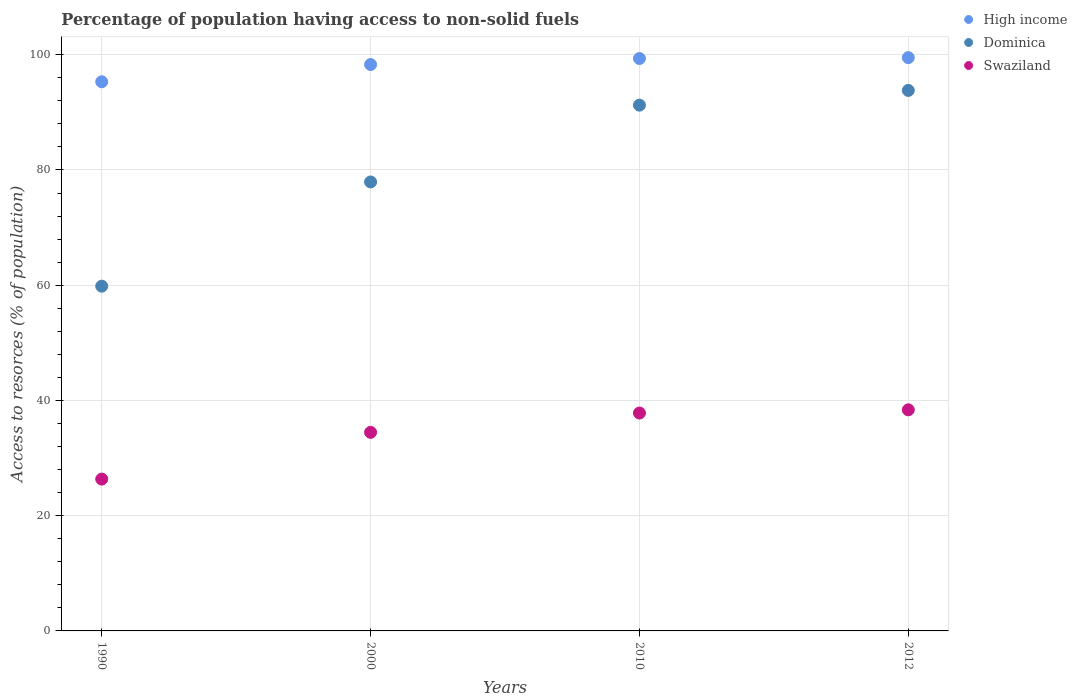Is the number of dotlines equal to the number of legend labels?
Your answer should be very brief. Yes. What is the percentage of population having access to non-solid fuels in Swaziland in 1990?
Offer a terse response. 26.35. Across all years, what is the maximum percentage of population having access to non-solid fuels in Dominica?
Give a very brief answer. 93.81. Across all years, what is the minimum percentage of population having access to non-solid fuels in Dominica?
Provide a succinct answer. 59.83. What is the total percentage of population having access to non-solid fuels in Swaziland in the graph?
Give a very brief answer. 137. What is the difference between the percentage of population having access to non-solid fuels in High income in 2000 and that in 2010?
Your response must be concise. -1.04. What is the difference between the percentage of population having access to non-solid fuels in Swaziland in 2000 and the percentage of population having access to non-solid fuels in High income in 2012?
Give a very brief answer. -65.03. What is the average percentage of population having access to non-solid fuels in Swaziland per year?
Make the answer very short. 34.25. In the year 2012, what is the difference between the percentage of population having access to non-solid fuels in High income and percentage of population having access to non-solid fuels in Dominica?
Make the answer very short. 5.69. In how many years, is the percentage of population having access to non-solid fuels in High income greater than 64 %?
Offer a terse response. 4. What is the ratio of the percentage of population having access to non-solid fuels in High income in 1990 to that in 2010?
Your response must be concise. 0.96. What is the difference between the highest and the second highest percentage of population having access to non-solid fuels in Dominica?
Provide a succinct answer. 2.56. What is the difference between the highest and the lowest percentage of population having access to non-solid fuels in Dominica?
Keep it short and to the point. 33.97. In how many years, is the percentage of population having access to non-solid fuels in Swaziland greater than the average percentage of population having access to non-solid fuels in Swaziland taken over all years?
Your answer should be compact. 3. Is it the case that in every year, the sum of the percentage of population having access to non-solid fuels in Swaziland and percentage of population having access to non-solid fuels in Dominica  is greater than the percentage of population having access to non-solid fuels in High income?
Your answer should be compact. No. Does the percentage of population having access to non-solid fuels in High income monotonically increase over the years?
Give a very brief answer. Yes. How many dotlines are there?
Make the answer very short. 3. Does the graph contain any zero values?
Keep it short and to the point. No. How many legend labels are there?
Your answer should be compact. 3. How are the legend labels stacked?
Offer a terse response. Vertical. What is the title of the graph?
Offer a terse response. Percentage of population having access to non-solid fuels. What is the label or title of the Y-axis?
Make the answer very short. Access to resorces (% of population). What is the Access to resorces (% of population) in High income in 1990?
Give a very brief answer. 95.31. What is the Access to resorces (% of population) in Dominica in 1990?
Your answer should be very brief. 59.83. What is the Access to resorces (% of population) of Swaziland in 1990?
Keep it short and to the point. 26.35. What is the Access to resorces (% of population) in High income in 2000?
Ensure brevity in your answer.  98.3. What is the Access to resorces (% of population) of Dominica in 2000?
Give a very brief answer. 77.92. What is the Access to resorces (% of population) of Swaziland in 2000?
Provide a succinct answer. 34.46. What is the Access to resorces (% of population) in High income in 2010?
Provide a succinct answer. 99.34. What is the Access to resorces (% of population) of Dominica in 2010?
Provide a short and direct response. 91.25. What is the Access to resorces (% of population) of Swaziland in 2010?
Provide a short and direct response. 37.82. What is the Access to resorces (% of population) in High income in 2012?
Keep it short and to the point. 99.49. What is the Access to resorces (% of population) of Dominica in 2012?
Offer a very short reply. 93.81. What is the Access to resorces (% of population) of Swaziland in 2012?
Ensure brevity in your answer.  38.37. Across all years, what is the maximum Access to resorces (% of population) in High income?
Your response must be concise. 99.49. Across all years, what is the maximum Access to resorces (% of population) in Dominica?
Give a very brief answer. 93.81. Across all years, what is the maximum Access to resorces (% of population) in Swaziland?
Offer a terse response. 38.37. Across all years, what is the minimum Access to resorces (% of population) of High income?
Provide a short and direct response. 95.31. Across all years, what is the minimum Access to resorces (% of population) of Dominica?
Your answer should be compact. 59.83. Across all years, what is the minimum Access to resorces (% of population) in Swaziland?
Make the answer very short. 26.35. What is the total Access to resorces (% of population) in High income in the graph?
Give a very brief answer. 392.44. What is the total Access to resorces (% of population) in Dominica in the graph?
Your response must be concise. 322.81. What is the total Access to resorces (% of population) in Swaziland in the graph?
Your answer should be compact. 137. What is the difference between the Access to resorces (% of population) of High income in 1990 and that in 2000?
Ensure brevity in your answer.  -2.99. What is the difference between the Access to resorces (% of population) of Dominica in 1990 and that in 2000?
Keep it short and to the point. -18.09. What is the difference between the Access to resorces (% of population) in Swaziland in 1990 and that in 2000?
Provide a succinct answer. -8.11. What is the difference between the Access to resorces (% of population) of High income in 1990 and that in 2010?
Your answer should be very brief. -4.04. What is the difference between the Access to resorces (% of population) in Dominica in 1990 and that in 2010?
Provide a succinct answer. -31.42. What is the difference between the Access to resorces (% of population) of Swaziland in 1990 and that in 2010?
Make the answer very short. -11.47. What is the difference between the Access to resorces (% of population) of High income in 1990 and that in 2012?
Your answer should be very brief. -4.19. What is the difference between the Access to resorces (% of population) in Dominica in 1990 and that in 2012?
Give a very brief answer. -33.97. What is the difference between the Access to resorces (% of population) in Swaziland in 1990 and that in 2012?
Your response must be concise. -12.02. What is the difference between the Access to resorces (% of population) in High income in 2000 and that in 2010?
Your response must be concise. -1.04. What is the difference between the Access to resorces (% of population) in Dominica in 2000 and that in 2010?
Your answer should be compact. -13.33. What is the difference between the Access to resorces (% of population) in Swaziland in 2000 and that in 2010?
Make the answer very short. -3.36. What is the difference between the Access to resorces (% of population) of High income in 2000 and that in 2012?
Your answer should be compact. -1.2. What is the difference between the Access to resorces (% of population) in Dominica in 2000 and that in 2012?
Give a very brief answer. -15.89. What is the difference between the Access to resorces (% of population) of Swaziland in 2000 and that in 2012?
Keep it short and to the point. -3.91. What is the difference between the Access to resorces (% of population) in High income in 2010 and that in 2012?
Your response must be concise. -0.15. What is the difference between the Access to resorces (% of population) of Dominica in 2010 and that in 2012?
Your answer should be very brief. -2.56. What is the difference between the Access to resorces (% of population) of Swaziland in 2010 and that in 2012?
Your response must be concise. -0.56. What is the difference between the Access to resorces (% of population) in High income in 1990 and the Access to resorces (% of population) in Dominica in 2000?
Make the answer very short. 17.39. What is the difference between the Access to resorces (% of population) of High income in 1990 and the Access to resorces (% of population) of Swaziland in 2000?
Give a very brief answer. 60.85. What is the difference between the Access to resorces (% of population) of Dominica in 1990 and the Access to resorces (% of population) of Swaziland in 2000?
Offer a terse response. 25.37. What is the difference between the Access to resorces (% of population) of High income in 1990 and the Access to resorces (% of population) of Dominica in 2010?
Provide a succinct answer. 4.06. What is the difference between the Access to resorces (% of population) of High income in 1990 and the Access to resorces (% of population) of Swaziland in 2010?
Give a very brief answer. 57.49. What is the difference between the Access to resorces (% of population) of Dominica in 1990 and the Access to resorces (% of population) of Swaziland in 2010?
Your response must be concise. 22.02. What is the difference between the Access to resorces (% of population) in High income in 1990 and the Access to resorces (% of population) in Dominica in 2012?
Give a very brief answer. 1.5. What is the difference between the Access to resorces (% of population) of High income in 1990 and the Access to resorces (% of population) of Swaziland in 2012?
Ensure brevity in your answer.  56.93. What is the difference between the Access to resorces (% of population) of Dominica in 1990 and the Access to resorces (% of population) of Swaziland in 2012?
Provide a succinct answer. 21.46. What is the difference between the Access to resorces (% of population) in High income in 2000 and the Access to resorces (% of population) in Dominica in 2010?
Offer a very short reply. 7.05. What is the difference between the Access to resorces (% of population) in High income in 2000 and the Access to resorces (% of population) in Swaziland in 2010?
Your response must be concise. 60.48. What is the difference between the Access to resorces (% of population) of Dominica in 2000 and the Access to resorces (% of population) of Swaziland in 2010?
Your answer should be very brief. 40.1. What is the difference between the Access to resorces (% of population) of High income in 2000 and the Access to resorces (% of population) of Dominica in 2012?
Offer a very short reply. 4.49. What is the difference between the Access to resorces (% of population) in High income in 2000 and the Access to resorces (% of population) in Swaziland in 2012?
Give a very brief answer. 59.92. What is the difference between the Access to resorces (% of population) of Dominica in 2000 and the Access to resorces (% of population) of Swaziland in 2012?
Ensure brevity in your answer.  39.54. What is the difference between the Access to resorces (% of population) of High income in 2010 and the Access to resorces (% of population) of Dominica in 2012?
Your response must be concise. 5.54. What is the difference between the Access to resorces (% of population) of High income in 2010 and the Access to resorces (% of population) of Swaziland in 2012?
Offer a terse response. 60.97. What is the difference between the Access to resorces (% of population) of Dominica in 2010 and the Access to resorces (% of population) of Swaziland in 2012?
Make the answer very short. 52.87. What is the average Access to resorces (% of population) in High income per year?
Your answer should be compact. 98.11. What is the average Access to resorces (% of population) in Dominica per year?
Your answer should be compact. 80.7. What is the average Access to resorces (% of population) of Swaziland per year?
Your answer should be very brief. 34.25. In the year 1990, what is the difference between the Access to resorces (% of population) of High income and Access to resorces (% of population) of Dominica?
Keep it short and to the point. 35.47. In the year 1990, what is the difference between the Access to resorces (% of population) in High income and Access to resorces (% of population) in Swaziland?
Your answer should be very brief. 68.96. In the year 1990, what is the difference between the Access to resorces (% of population) in Dominica and Access to resorces (% of population) in Swaziland?
Keep it short and to the point. 33.48. In the year 2000, what is the difference between the Access to resorces (% of population) of High income and Access to resorces (% of population) of Dominica?
Offer a terse response. 20.38. In the year 2000, what is the difference between the Access to resorces (% of population) in High income and Access to resorces (% of population) in Swaziland?
Keep it short and to the point. 63.84. In the year 2000, what is the difference between the Access to resorces (% of population) of Dominica and Access to resorces (% of population) of Swaziland?
Provide a succinct answer. 43.46. In the year 2010, what is the difference between the Access to resorces (% of population) of High income and Access to resorces (% of population) of Dominica?
Provide a short and direct response. 8.09. In the year 2010, what is the difference between the Access to resorces (% of population) of High income and Access to resorces (% of population) of Swaziland?
Your response must be concise. 61.53. In the year 2010, what is the difference between the Access to resorces (% of population) in Dominica and Access to resorces (% of population) in Swaziland?
Your response must be concise. 53.43. In the year 2012, what is the difference between the Access to resorces (% of population) of High income and Access to resorces (% of population) of Dominica?
Your response must be concise. 5.69. In the year 2012, what is the difference between the Access to resorces (% of population) in High income and Access to resorces (% of population) in Swaziland?
Keep it short and to the point. 61.12. In the year 2012, what is the difference between the Access to resorces (% of population) of Dominica and Access to resorces (% of population) of Swaziland?
Make the answer very short. 55.43. What is the ratio of the Access to resorces (% of population) in High income in 1990 to that in 2000?
Your answer should be very brief. 0.97. What is the ratio of the Access to resorces (% of population) of Dominica in 1990 to that in 2000?
Make the answer very short. 0.77. What is the ratio of the Access to resorces (% of population) of Swaziland in 1990 to that in 2000?
Offer a terse response. 0.76. What is the ratio of the Access to resorces (% of population) in High income in 1990 to that in 2010?
Offer a terse response. 0.96. What is the ratio of the Access to resorces (% of population) of Dominica in 1990 to that in 2010?
Give a very brief answer. 0.66. What is the ratio of the Access to resorces (% of population) in Swaziland in 1990 to that in 2010?
Your response must be concise. 0.7. What is the ratio of the Access to resorces (% of population) in High income in 1990 to that in 2012?
Your response must be concise. 0.96. What is the ratio of the Access to resorces (% of population) in Dominica in 1990 to that in 2012?
Your answer should be very brief. 0.64. What is the ratio of the Access to resorces (% of population) in Swaziland in 1990 to that in 2012?
Your response must be concise. 0.69. What is the ratio of the Access to resorces (% of population) in High income in 2000 to that in 2010?
Provide a short and direct response. 0.99. What is the ratio of the Access to resorces (% of population) in Dominica in 2000 to that in 2010?
Your response must be concise. 0.85. What is the ratio of the Access to resorces (% of population) of Swaziland in 2000 to that in 2010?
Give a very brief answer. 0.91. What is the ratio of the Access to resorces (% of population) in High income in 2000 to that in 2012?
Ensure brevity in your answer.  0.99. What is the ratio of the Access to resorces (% of population) of Dominica in 2000 to that in 2012?
Give a very brief answer. 0.83. What is the ratio of the Access to resorces (% of population) of Swaziland in 2000 to that in 2012?
Your answer should be very brief. 0.9. What is the ratio of the Access to resorces (% of population) in High income in 2010 to that in 2012?
Keep it short and to the point. 1. What is the ratio of the Access to resorces (% of population) of Dominica in 2010 to that in 2012?
Make the answer very short. 0.97. What is the ratio of the Access to resorces (% of population) in Swaziland in 2010 to that in 2012?
Offer a very short reply. 0.99. What is the difference between the highest and the second highest Access to resorces (% of population) in High income?
Your answer should be very brief. 0.15. What is the difference between the highest and the second highest Access to resorces (% of population) of Dominica?
Offer a terse response. 2.56. What is the difference between the highest and the second highest Access to resorces (% of population) in Swaziland?
Provide a succinct answer. 0.56. What is the difference between the highest and the lowest Access to resorces (% of population) in High income?
Make the answer very short. 4.19. What is the difference between the highest and the lowest Access to resorces (% of population) of Dominica?
Make the answer very short. 33.97. What is the difference between the highest and the lowest Access to resorces (% of population) of Swaziland?
Ensure brevity in your answer.  12.02. 